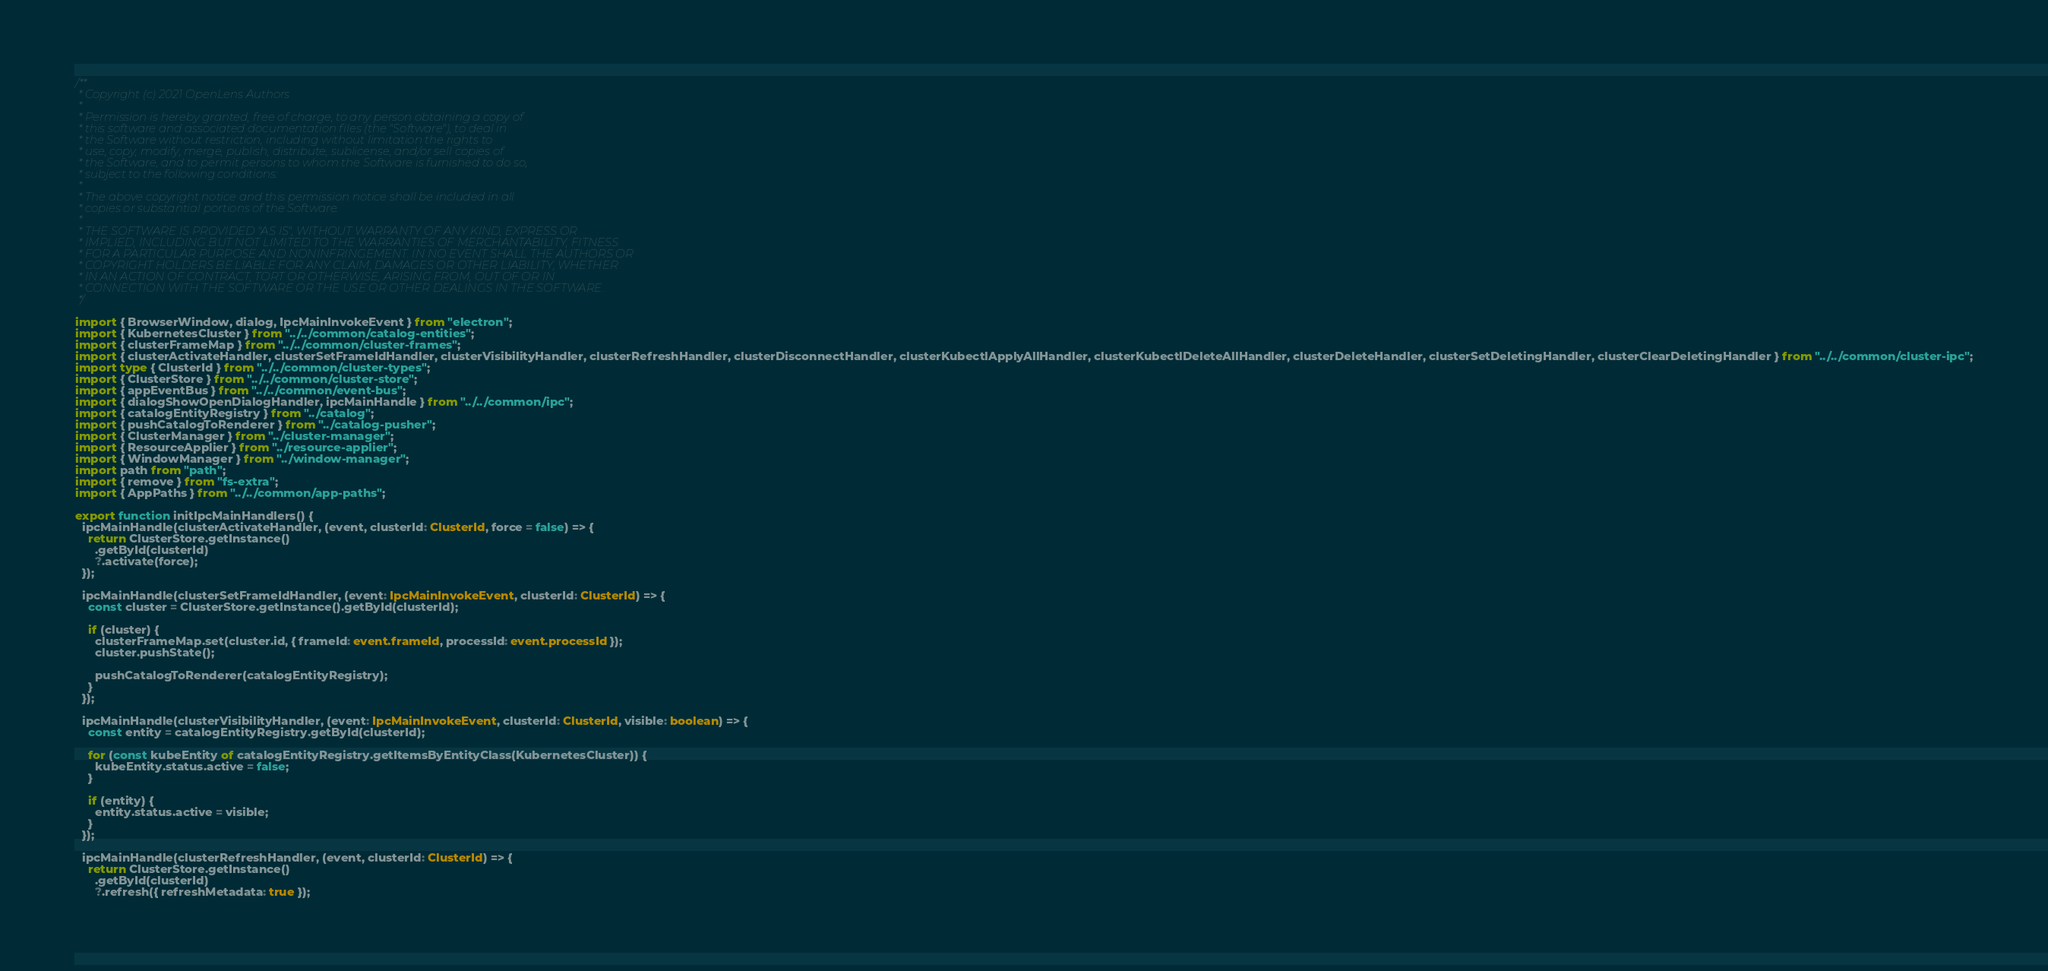<code> <loc_0><loc_0><loc_500><loc_500><_TypeScript_>/**
 * Copyright (c) 2021 OpenLens Authors
 *
 * Permission is hereby granted, free of charge, to any person obtaining a copy of
 * this software and associated documentation files (the "Software"), to deal in
 * the Software without restriction, including without limitation the rights to
 * use, copy, modify, merge, publish, distribute, sublicense, and/or sell copies of
 * the Software, and to permit persons to whom the Software is furnished to do so,
 * subject to the following conditions:
 *
 * The above copyright notice and this permission notice shall be included in all
 * copies or substantial portions of the Software.
 *
 * THE SOFTWARE IS PROVIDED "AS IS", WITHOUT WARRANTY OF ANY KIND, EXPRESS OR
 * IMPLIED, INCLUDING BUT NOT LIMITED TO THE WARRANTIES OF MERCHANTABILITY, FITNESS
 * FOR A PARTICULAR PURPOSE AND NONINFRINGEMENT. IN NO EVENT SHALL THE AUTHORS OR
 * COPYRIGHT HOLDERS BE LIABLE FOR ANY CLAIM, DAMAGES OR OTHER LIABILITY, WHETHER
 * IN AN ACTION OF CONTRACT, TORT OR OTHERWISE, ARISING FROM, OUT OF OR IN
 * CONNECTION WITH THE SOFTWARE OR THE USE OR OTHER DEALINGS IN THE SOFTWARE.
 */

import { BrowserWindow, dialog, IpcMainInvokeEvent } from "electron";
import { KubernetesCluster } from "../../common/catalog-entities";
import { clusterFrameMap } from "../../common/cluster-frames";
import { clusterActivateHandler, clusterSetFrameIdHandler, clusterVisibilityHandler, clusterRefreshHandler, clusterDisconnectHandler, clusterKubectlApplyAllHandler, clusterKubectlDeleteAllHandler, clusterDeleteHandler, clusterSetDeletingHandler, clusterClearDeletingHandler } from "../../common/cluster-ipc";
import type { ClusterId } from "../../common/cluster-types";
import { ClusterStore } from "../../common/cluster-store";
import { appEventBus } from "../../common/event-bus";
import { dialogShowOpenDialogHandler, ipcMainHandle } from "../../common/ipc";
import { catalogEntityRegistry } from "../catalog";
import { pushCatalogToRenderer } from "../catalog-pusher";
import { ClusterManager } from "../cluster-manager";
import { ResourceApplier } from "../resource-applier";
import { WindowManager } from "../window-manager";
import path from "path";
import { remove } from "fs-extra";
import { AppPaths } from "../../common/app-paths";

export function initIpcMainHandlers() {
  ipcMainHandle(clusterActivateHandler, (event, clusterId: ClusterId, force = false) => {
    return ClusterStore.getInstance()
      .getById(clusterId)
      ?.activate(force);
  });

  ipcMainHandle(clusterSetFrameIdHandler, (event: IpcMainInvokeEvent, clusterId: ClusterId) => {
    const cluster = ClusterStore.getInstance().getById(clusterId);

    if (cluster) {
      clusterFrameMap.set(cluster.id, { frameId: event.frameId, processId: event.processId });
      cluster.pushState();

      pushCatalogToRenderer(catalogEntityRegistry);
    }
  });

  ipcMainHandle(clusterVisibilityHandler, (event: IpcMainInvokeEvent, clusterId: ClusterId, visible: boolean) => {
    const entity = catalogEntityRegistry.getById(clusterId);

    for (const kubeEntity of catalogEntityRegistry.getItemsByEntityClass(KubernetesCluster)) {
      kubeEntity.status.active = false;
    }

    if (entity) {
      entity.status.active = visible;
    }
  });

  ipcMainHandle(clusterRefreshHandler, (event, clusterId: ClusterId) => {
    return ClusterStore.getInstance()
      .getById(clusterId)
      ?.refresh({ refreshMetadata: true });</code> 